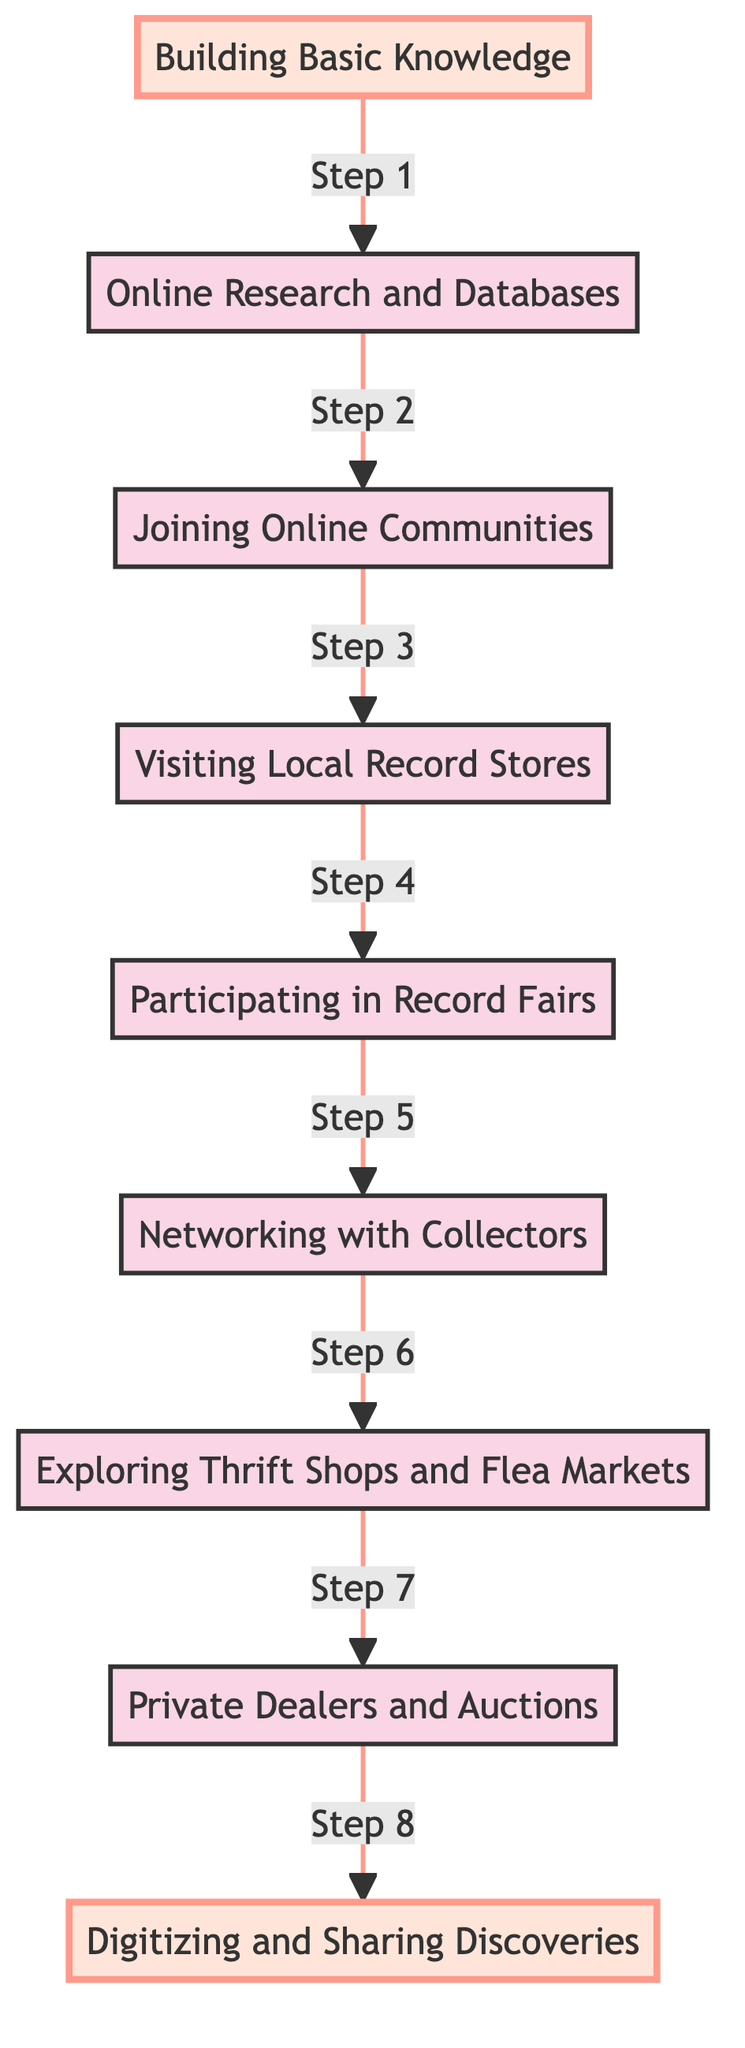What is the starting point of this flow chart? The starting point of the flow chart is "Building Basic Knowledge." This is the first element at the bottom of the diagram, indicating where the process begins.
Answer: Building Basic Knowledge What is the final step in this flow chart? The final step in the flow chart is "Digitizing and Sharing Discoveries," which is located at the top of the diagram, indicating the end goal of the process.
Answer: Digitizing and Sharing Discoveries How many steps are there in total within this flow chart? There are a total of eight steps in the flow chart, counted from "Building Basic Knowledge" to "Digitizing and Sharing Discoveries."
Answer: Eight Which step follows "Participating in Record Fairs"? The step that follows "Participating in Record Fairs" is "Networking with Collectors." This follows the flow from one step to the next in the diagram.
Answer: Networking with Collectors What relationship do "Joining Online Communities" and "Visiting Local Record Stores" share? "Joining Online Communities" is immediately followed by "Visiting Local Record Stores," indicating that these two steps are sequential; knowledge gained may lead to visits to local stores.
Answer: Sequential What is the connection between "Exploring Thrift Shops and Flea Markets" and "Private Dealers and Auctions"? "Exploring Thrift Shops and Flea Markets" directly leads to "Private Dealers and Auctions," indicating a progression from casual searching to more specialized dealing in vinyl.
Answer: Progression What step does one engage in after "Online Research and Databases"? After "Online Research and Databases," one engages in "Joining Online Communities." This shows a logical progression from research to community engagement for further learning.
Answer: Joining Online Communities How does the placement of "Building Basic Knowledge" influence the flow of the diagram? "Building Basic Knowledge" is at the bottom, suggesting that it is foundational to all subsequent actions in the flow, emphasizing that knowledge is the starting point for all discoveries.
Answer: Foundational 